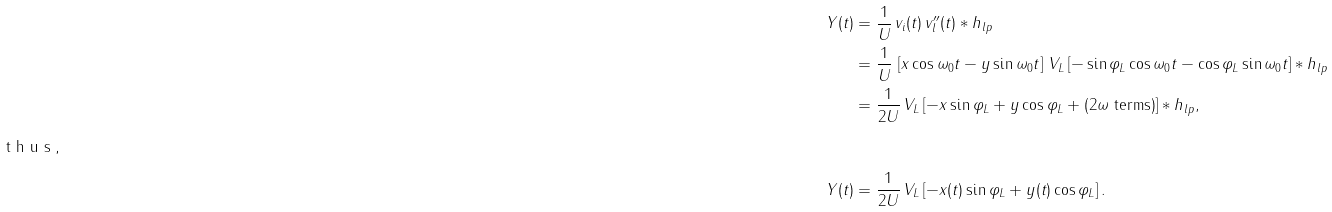Convert formula to latex. <formula><loc_0><loc_0><loc_500><loc_500>Y ( t ) & = \frac { 1 } { U } \, v _ { i } ( t ) \, v ^ { \prime \prime } _ { l } ( t ) * h _ { l p } \\ & = \frac { 1 } { U } \, \left [ x \cos \omega _ { 0 } t - y \sin \omega _ { 0 } t \right ] \, V _ { L } \left [ - \sin \varphi _ { L } \cos \omega _ { 0 } t - \cos \varphi _ { L } \sin \omega _ { 0 } t \right ] * h _ { l p } \\ & = \frac { 1 } { 2 U } \, V _ { L } \left [ - x \sin \varphi _ { L } + y \cos \varphi _ { L } + \text {($2\omega$ terms)} \right ] * h _ { l p } , \\ \intertext { t h u s , } Y ( t ) & = \frac { 1 } { 2 U } \, V _ { L } \left [ - x ( t ) \sin \varphi _ { L } + y ( t ) \cos \varphi _ { L } \right ] .</formula> 